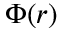Convert formula to latex. <formula><loc_0><loc_0><loc_500><loc_500>\Phi ( r )</formula> 